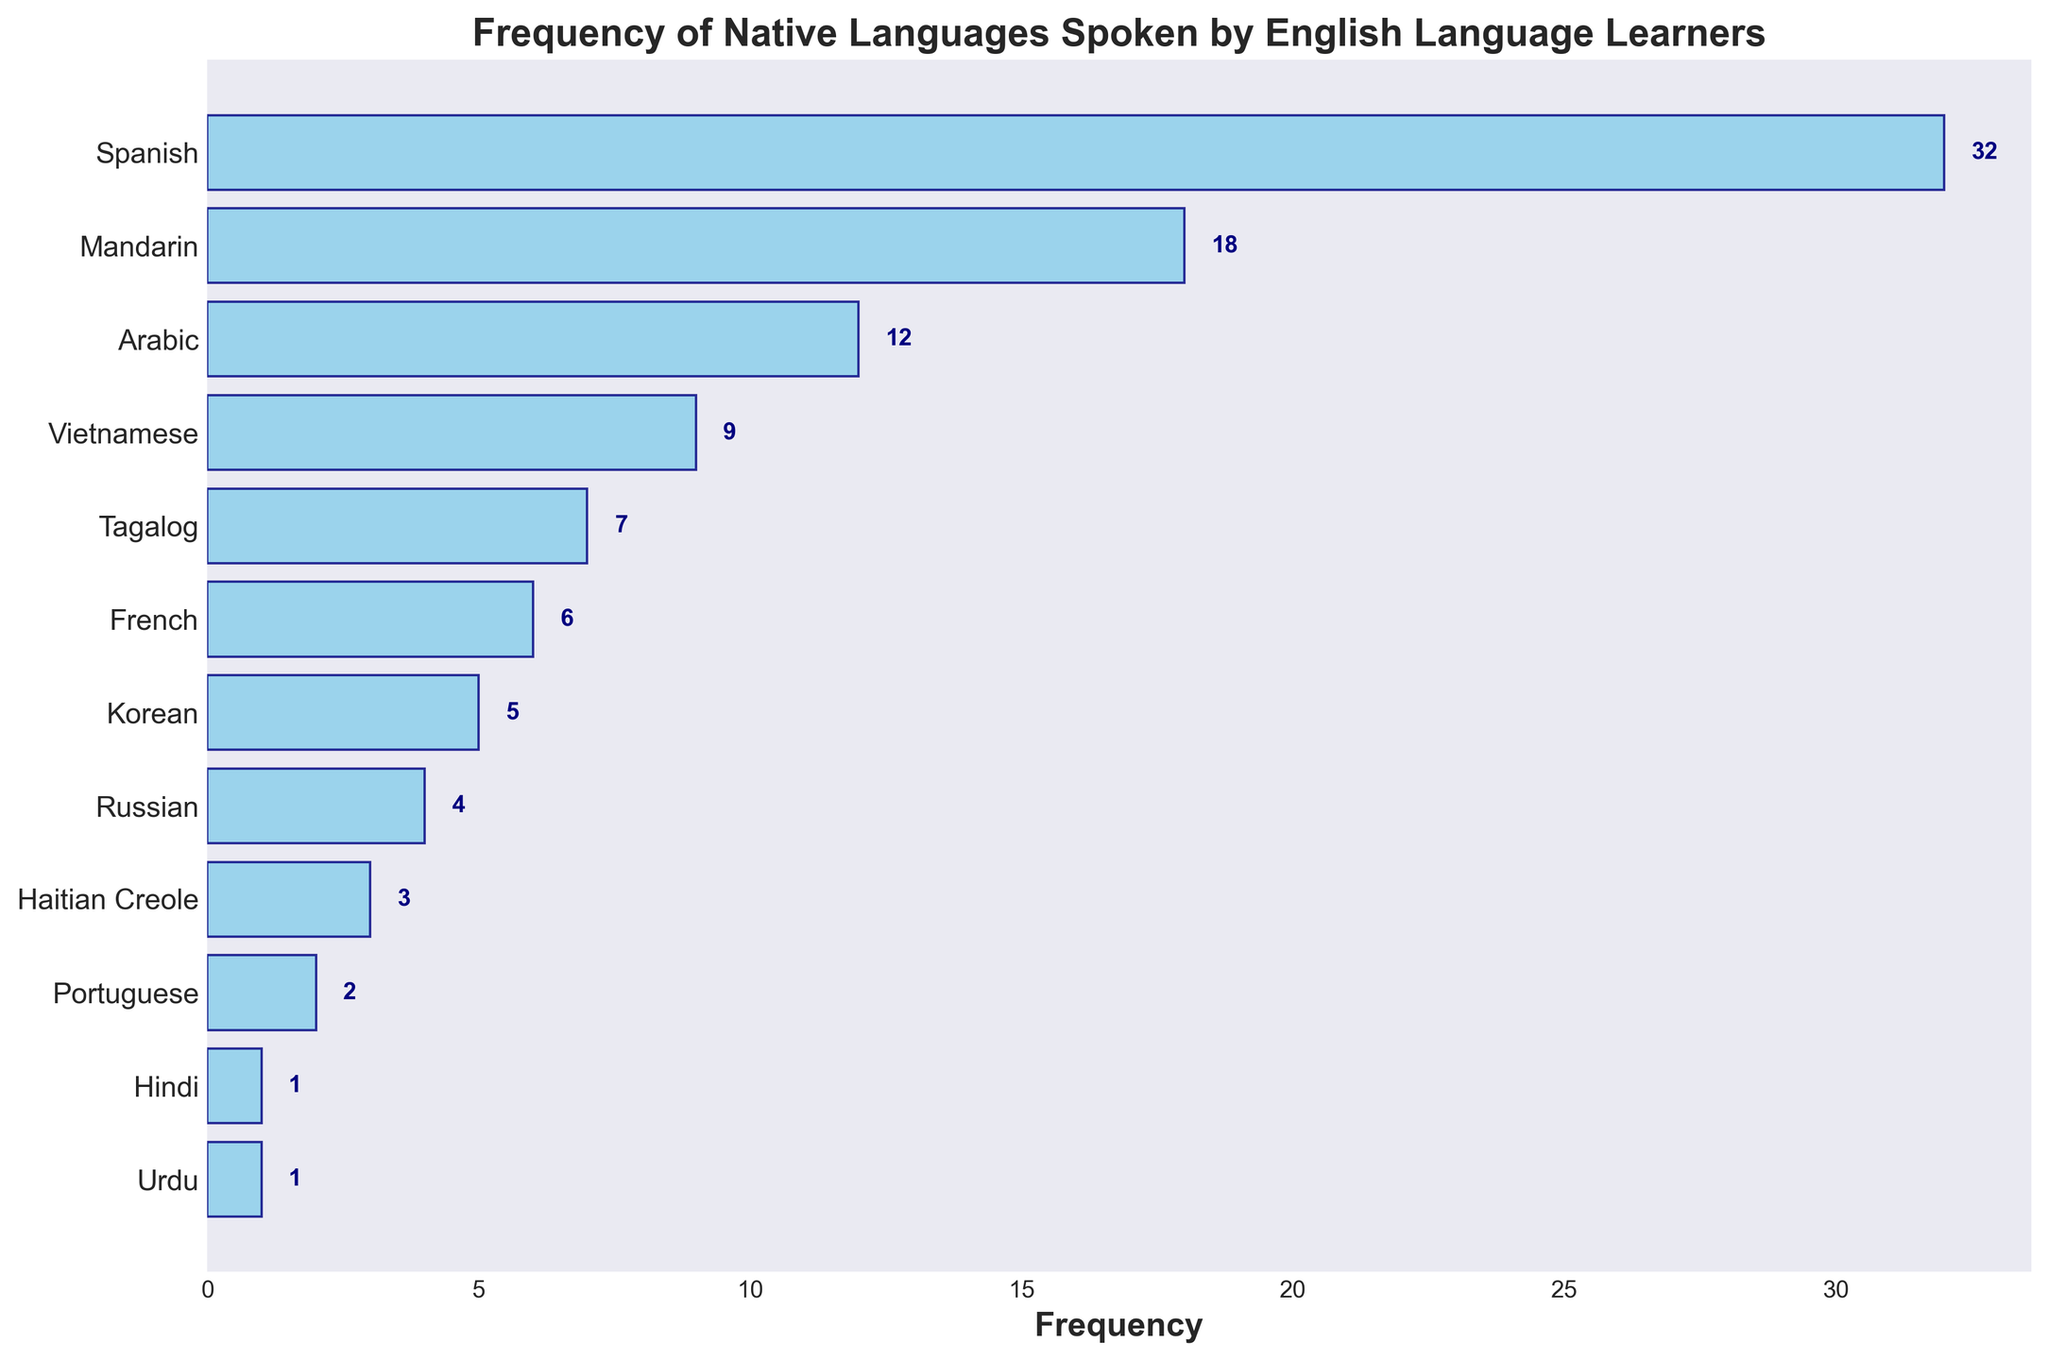What's the most frequently spoken native language by English language learners in the classroom? By looking at the bar that extends farthest to the right, we see that Spanish has the highest frequency.
Answer: Spanish What is the title of the plot? The title is placed atop the figure prominently. It reads: "Frequency of Native Languages Spoken by English Language Learners".
Answer: Frequency of Native Languages Spoken by English Language Learners How many native languages are represented in the plot? By counting the number of bars or y-axis labels, there are 12 different native languages represented in the plot.
Answer: 12 Which native language has the least frequency and what is that frequency? By locating the shortest bar on the plot, Urdu and Hindi are seen tied for the lowest frequency with 1 each.
Answer: Urdu and Hindi, 1 What is the combined frequency of Mandarin and Arabic speakers? Mandarin has a frequency of 18, and Arabic has a frequency of 12. Combined: 18 + 12 = 30.
Answer: 30 How much higher is the frequency of Spanish compared to Vietnamese? The frequency of Spanish is 32, while Vietnamese has a frequency of 9. The difference is 32 - 9 = 23.
Answer: 23 Which languages have a frequency greater than 10? By looking at the bars extending past the 10 mark, the languages are Spanish (32), Mandarin (18), and Arabic (12).
Answer: Spanish, Mandarin, Arabic What is the average frequency of native languages spoken by English learners in the classroom? Sum the frequencies: 32 + 18 + 12 + 9 + 7 + 6 + 5 + 4 + 3 + 2 + 1 + 1 = 100. Divide by the number of languages: 100 / 12 ≈ 8.33.
Answer: 8.33 Is Korean spoken less frequently than French? By comparing the lengths of the corresponding bars, Korean has a frequency of 5 while French has a frequency of 6, showing Korean is spoken less frequently.
Answer: Yes What languages have frequencies between 5 and 10, inclusive? By identifying the bars within this range, the languages are Vietnamese (9), Tagalog (7), French (6), and Korean (5).
Answer: Vietnamese, Tagalog, French, Korean 